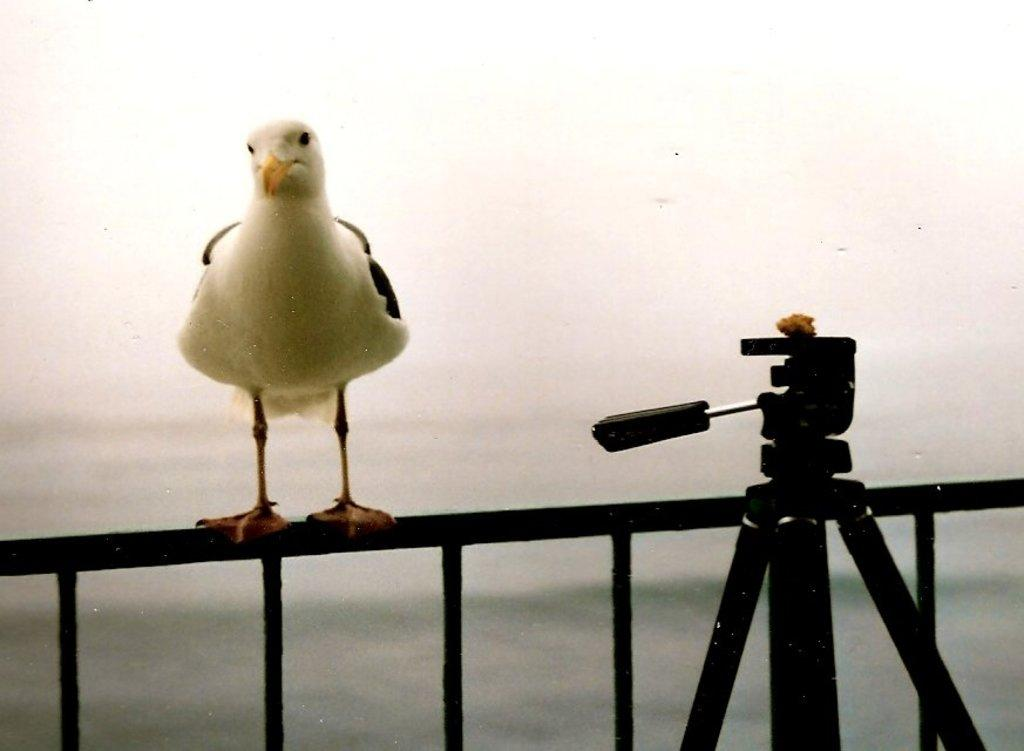What type of animal is in the image? There is a bird in the image. Where is the bird located? The bird is standing on an iron grille. What else can be seen in the image? There is a tripod stand in the image. Can you describe the background of the image? The background of the image is blurry. What type of brush can be seen in the image? There is no brush present in the image. 